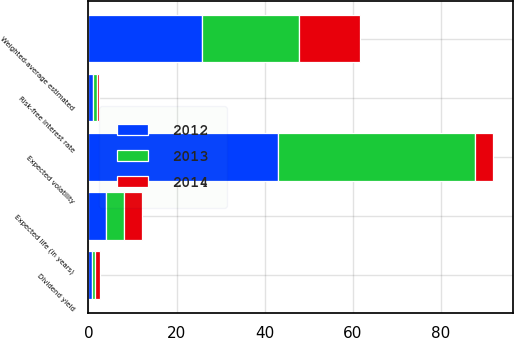Convert chart. <chart><loc_0><loc_0><loc_500><loc_500><stacked_bar_chart><ecel><fcel>Risk-free interest rate<fcel>Expected volatility<fcel>Expected life (in years)<fcel>Dividend yield<fcel>Weighted-average estimated<nl><fcel>2012<fcel>1.13<fcel>42.97<fcel>4.04<fcel>0.76<fcel>25.8<nl><fcel>2013<fcel>0.71<fcel>44.81<fcel>4.07<fcel>0.8<fcel>21.96<nl><fcel>2014<fcel>0.64<fcel>4.02<fcel>4<fcel>1.04<fcel>13.96<nl></chart> 